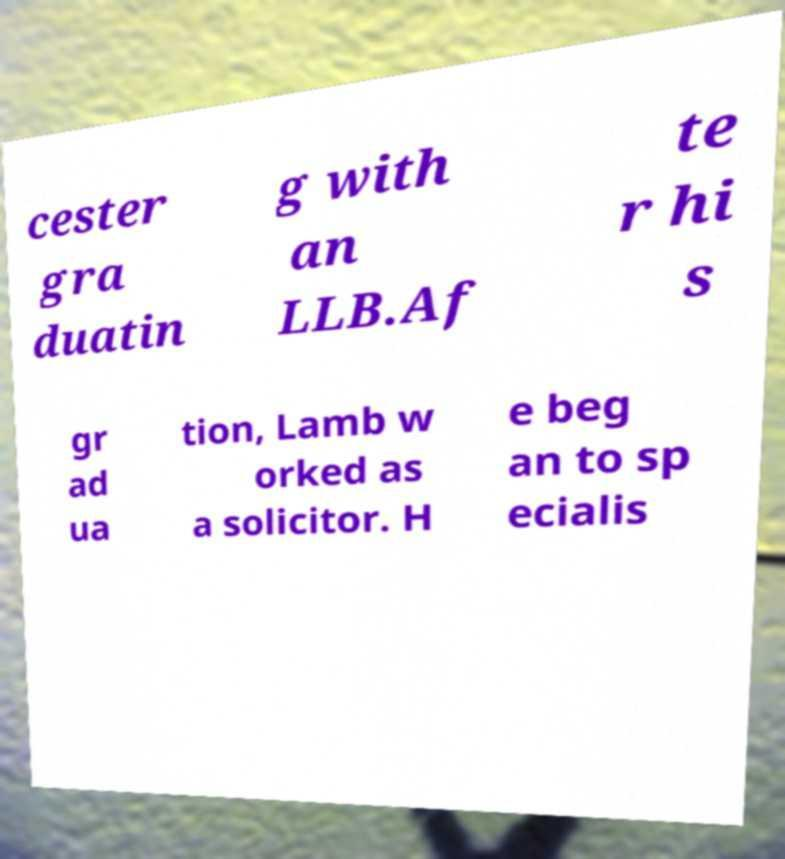For documentation purposes, I need the text within this image transcribed. Could you provide that? cester gra duatin g with an LLB.Af te r hi s gr ad ua tion, Lamb w orked as a solicitor. H e beg an to sp ecialis 